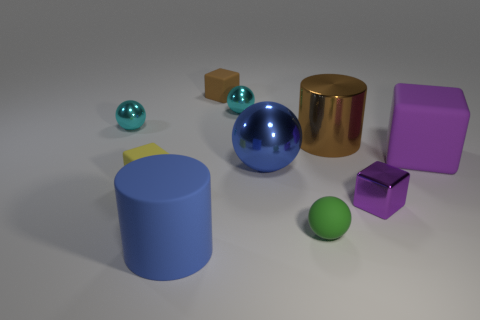How many things are either metallic spheres that are on the left side of the yellow rubber thing or tiny brown rubber blocks?
Your response must be concise. 2. Do the tiny purple block and the big cylinder that is on the right side of the matte ball have the same material?
Ensure brevity in your answer.  Yes. The matte thing that is to the right of the large metallic object behind the big purple cube is what shape?
Ensure brevity in your answer.  Cube. Does the tiny metallic block have the same color as the big matte thing that is on the right side of the blue cylinder?
Your answer should be very brief. Yes. What shape is the small purple object?
Provide a short and direct response. Cube. What size is the cyan shiny sphere right of the big matte object that is on the left side of the purple matte cube?
Give a very brief answer. Small. Are there an equal number of rubber spheres behind the tiny purple thing and matte cylinders behind the big brown metallic cylinder?
Your response must be concise. Yes. What is the big thing that is left of the tiny green object and behind the tiny purple shiny cube made of?
Make the answer very short. Metal. Do the green rubber sphere and the cyan metal thing on the left side of the tiny yellow rubber object have the same size?
Give a very brief answer. Yes. How many other objects are the same color as the matte ball?
Ensure brevity in your answer.  0. 